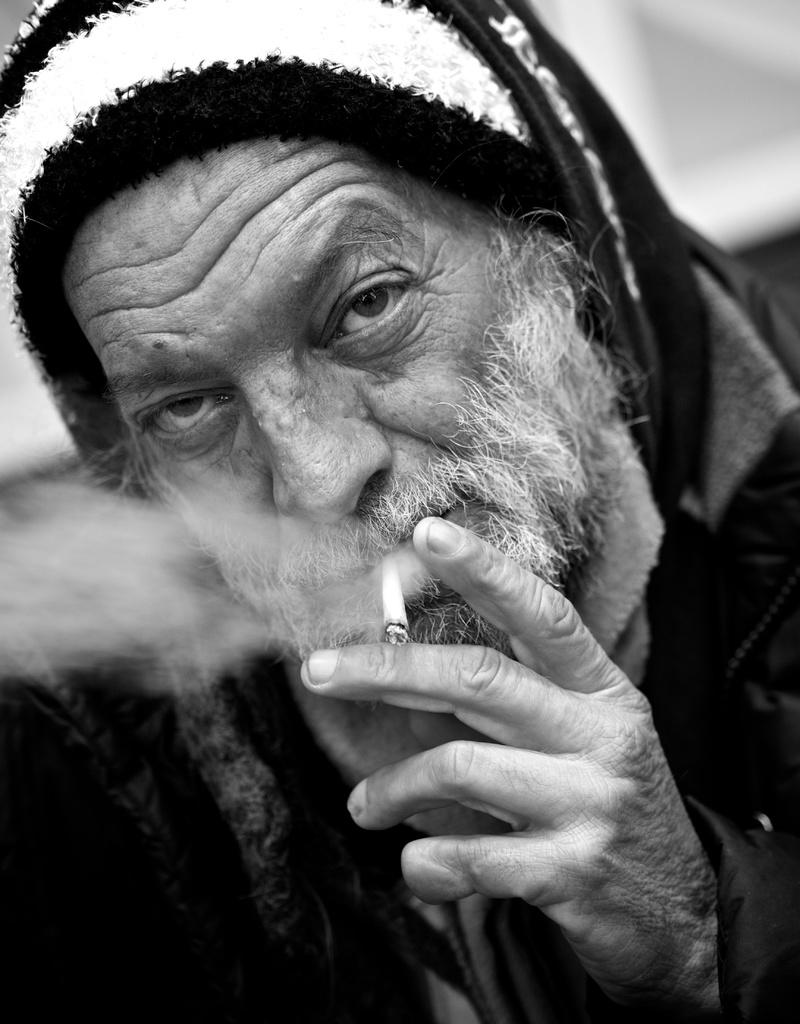What is the color scheme of the image? The image is in black and white. Who is the main subject in the image? There is an old man in the image. What clothing items is the old man wearing? The old man is wearing a jacket and a cap. What is the old man doing in the image? The old man is smoking a cigarette. How far away is the bee from the old man in the image? There is no bee present in the image, so it is not possible to determine the distance between the old man and a bee. 